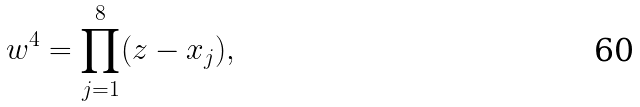<formula> <loc_0><loc_0><loc_500><loc_500>w ^ { 4 } = \prod _ { j = 1 } ^ { 8 } ( z - x _ { j } ) ,</formula> 